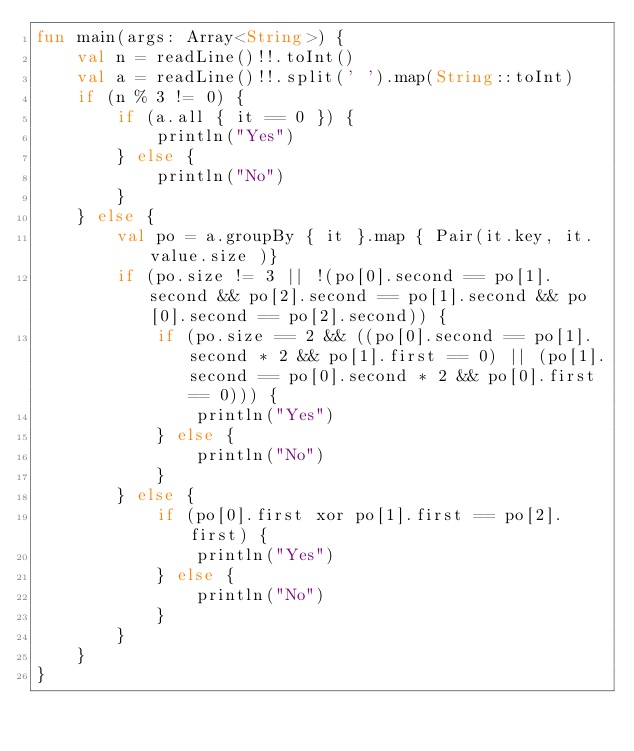Convert code to text. <code><loc_0><loc_0><loc_500><loc_500><_Kotlin_>fun main(args: Array<String>) {
    val n = readLine()!!.toInt()
    val a = readLine()!!.split(' ').map(String::toInt)
    if (n % 3 != 0) {
        if (a.all { it == 0 }) {
            println("Yes")
        } else {
            println("No")
        }
    } else {
        val po = a.groupBy { it }.map { Pair(it.key, it.value.size )}
        if (po.size != 3 || !(po[0].second == po[1].second && po[2].second == po[1].second && po[0].second == po[2].second)) {
            if (po.size == 2 && ((po[0].second == po[1].second * 2 && po[1].first == 0) || (po[1].second == po[0].second * 2 && po[0].first == 0))) {
                println("Yes")
            } else {
                println("No")
            }
        } else {
            if (po[0].first xor po[1].first == po[2].first) {
                println("Yes")
            } else {
                println("No")
            }
        }
    }
}
</code> 